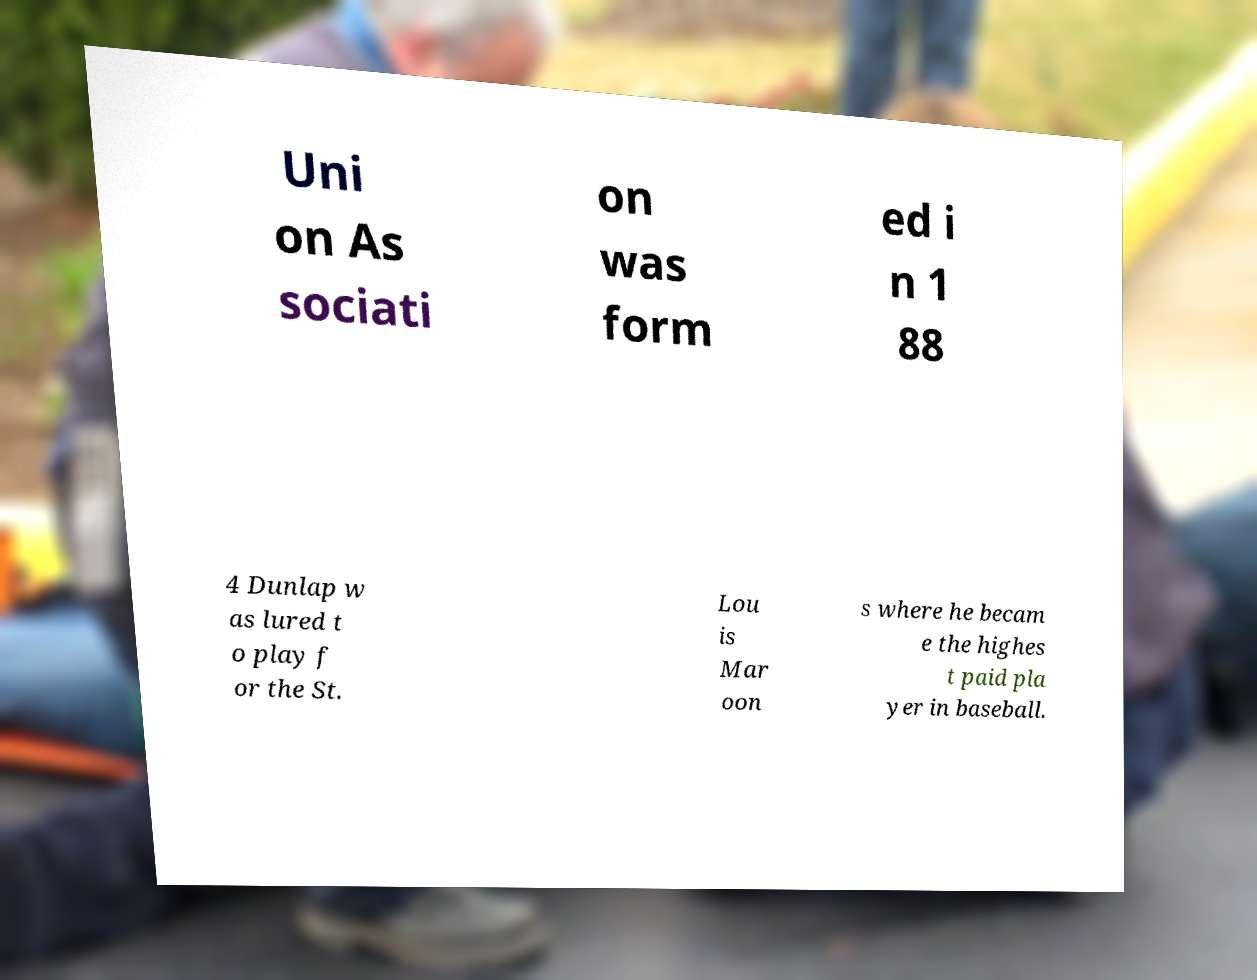There's text embedded in this image that I need extracted. Can you transcribe it verbatim? Uni on As sociati on was form ed i n 1 88 4 Dunlap w as lured t o play f or the St. Lou is Mar oon s where he becam e the highes t paid pla yer in baseball. 